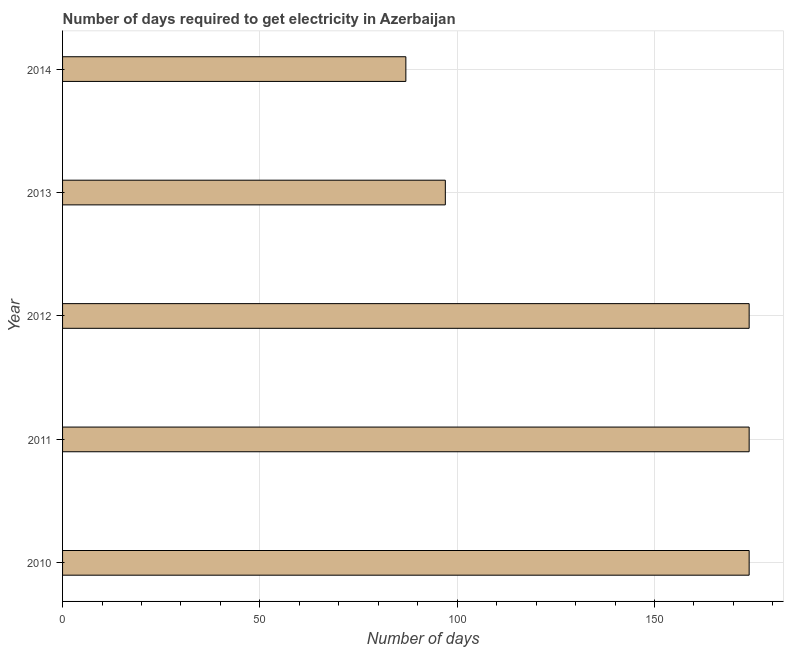Does the graph contain any zero values?
Keep it short and to the point. No. Does the graph contain grids?
Provide a short and direct response. Yes. What is the title of the graph?
Your answer should be compact. Number of days required to get electricity in Azerbaijan. What is the label or title of the X-axis?
Give a very brief answer. Number of days. What is the time to get electricity in 2010?
Provide a short and direct response. 174. Across all years, what is the maximum time to get electricity?
Offer a terse response. 174. Across all years, what is the minimum time to get electricity?
Make the answer very short. 87. What is the sum of the time to get electricity?
Your answer should be very brief. 706. What is the average time to get electricity per year?
Offer a terse response. 141. What is the median time to get electricity?
Your response must be concise. 174. In how many years, is the time to get electricity greater than 20 ?
Keep it short and to the point. 5. Do a majority of the years between 2011 and 2013 (inclusive) have time to get electricity greater than 170 ?
Offer a terse response. Yes. What is the ratio of the time to get electricity in 2012 to that in 2014?
Provide a succinct answer. 2. Is the time to get electricity in 2010 less than that in 2011?
Your response must be concise. No. What is the difference between the highest and the second highest time to get electricity?
Offer a very short reply. 0. Is the sum of the time to get electricity in 2013 and 2014 greater than the maximum time to get electricity across all years?
Your answer should be very brief. Yes. What is the difference between two consecutive major ticks on the X-axis?
Provide a short and direct response. 50. Are the values on the major ticks of X-axis written in scientific E-notation?
Offer a very short reply. No. What is the Number of days in 2010?
Your response must be concise. 174. What is the Number of days in 2011?
Your answer should be compact. 174. What is the Number of days in 2012?
Offer a terse response. 174. What is the Number of days in 2013?
Your answer should be compact. 97. What is the Number of days of 2014?
Make the answer very short. 87. What is the difference between the Number of days in 2010 and 2011?
Ensure brevity in your answer.  0. What is the difference between the Number of days in 2010 and 2012?
Give a very brief answer. 0. What is the difference between the Number of days in 2010 and 2014?
Offer a terse response. 87. What is the difference between the Number of days in 2011 and 2013?
Give a very brief answer. 77. What is the difference between the Number of days in 2012 and 2013?
Ensure brevity in your answer.  77. What is the difference between the Number of days in 2012 and 2014?
Your answer should be very brief. 87. What is the ratio of the Number of days in 2010 to that in 2011?
Provide a succinct answer. 1. What is the ratio of the Number of days in 2010 to that in 2012?
Make the answer very short. 1. What is the ratio of the Number of days in 2010 to that in 2013?
Give a very brief answer. 1.79. What is the ratio of the Number of days in 2010 to that in 2014?
Make the answer very short. 2. What is the ratio of the Number of days in 2011 to that in 2012?
Ensure brevity in your answer.  1. What is the ratio of the Number of days in 2011 to that in 2013?
Offer a terse response. 1.79. What is the ratio of the Number of days in 2012 to that in 2013?
Provide a succinct answer. 1.79. What is the ratio of the Number of days in 2013 to that in 2014?
Ensure brevity in your answer.  1.11. 